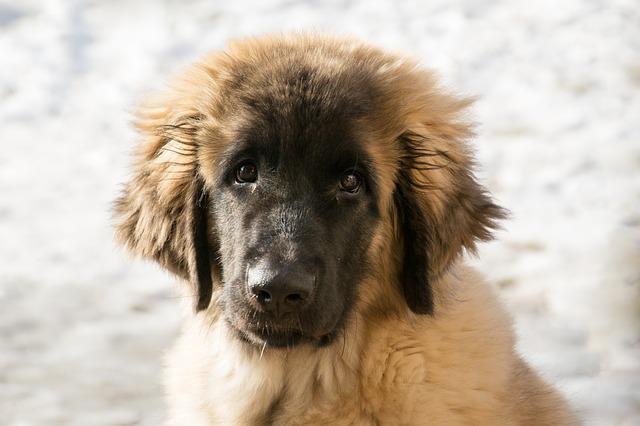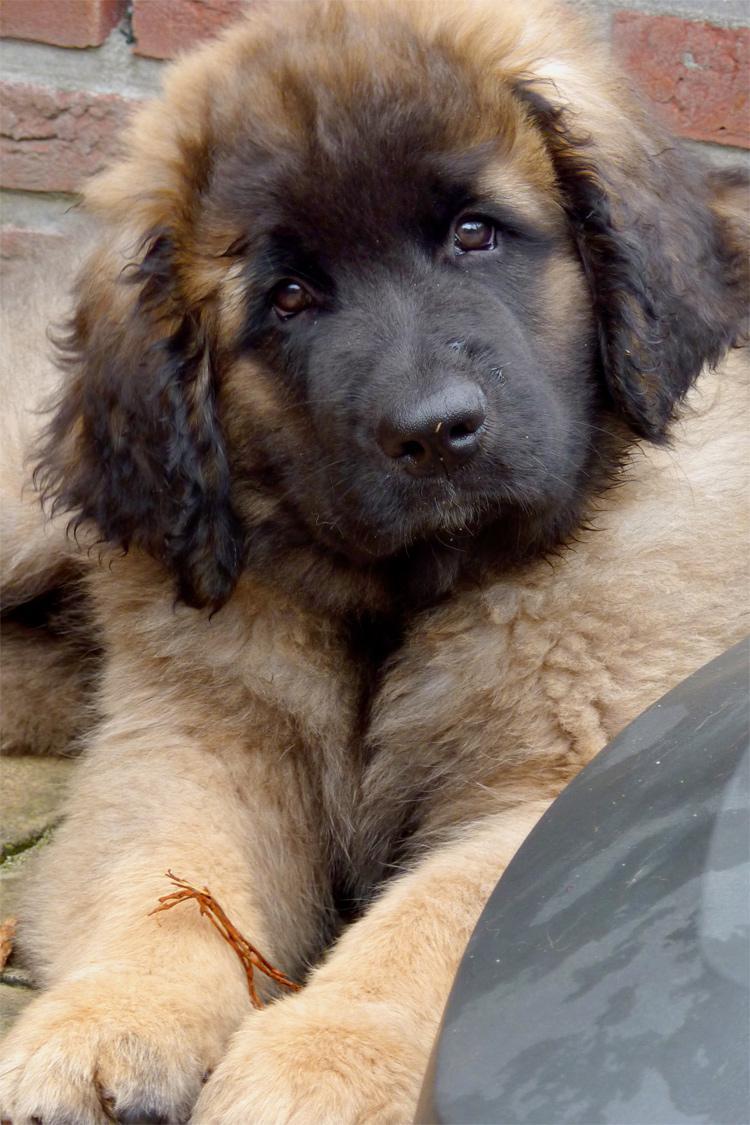The first image is the image on the left, the second image is the image on the right. Given the left and right images, does the statement "The dog in one of the images is lying down on the carpet." hold true? Answer yes or no. No. The first image is the image on the left, the second image is the image on the right. Evaluate the accuracy of this statement regarding the images: "The dogs in the two images are looking in the same direction, and no dog has its tongue showing.". Is it true? Answer yes or no. Yes. 